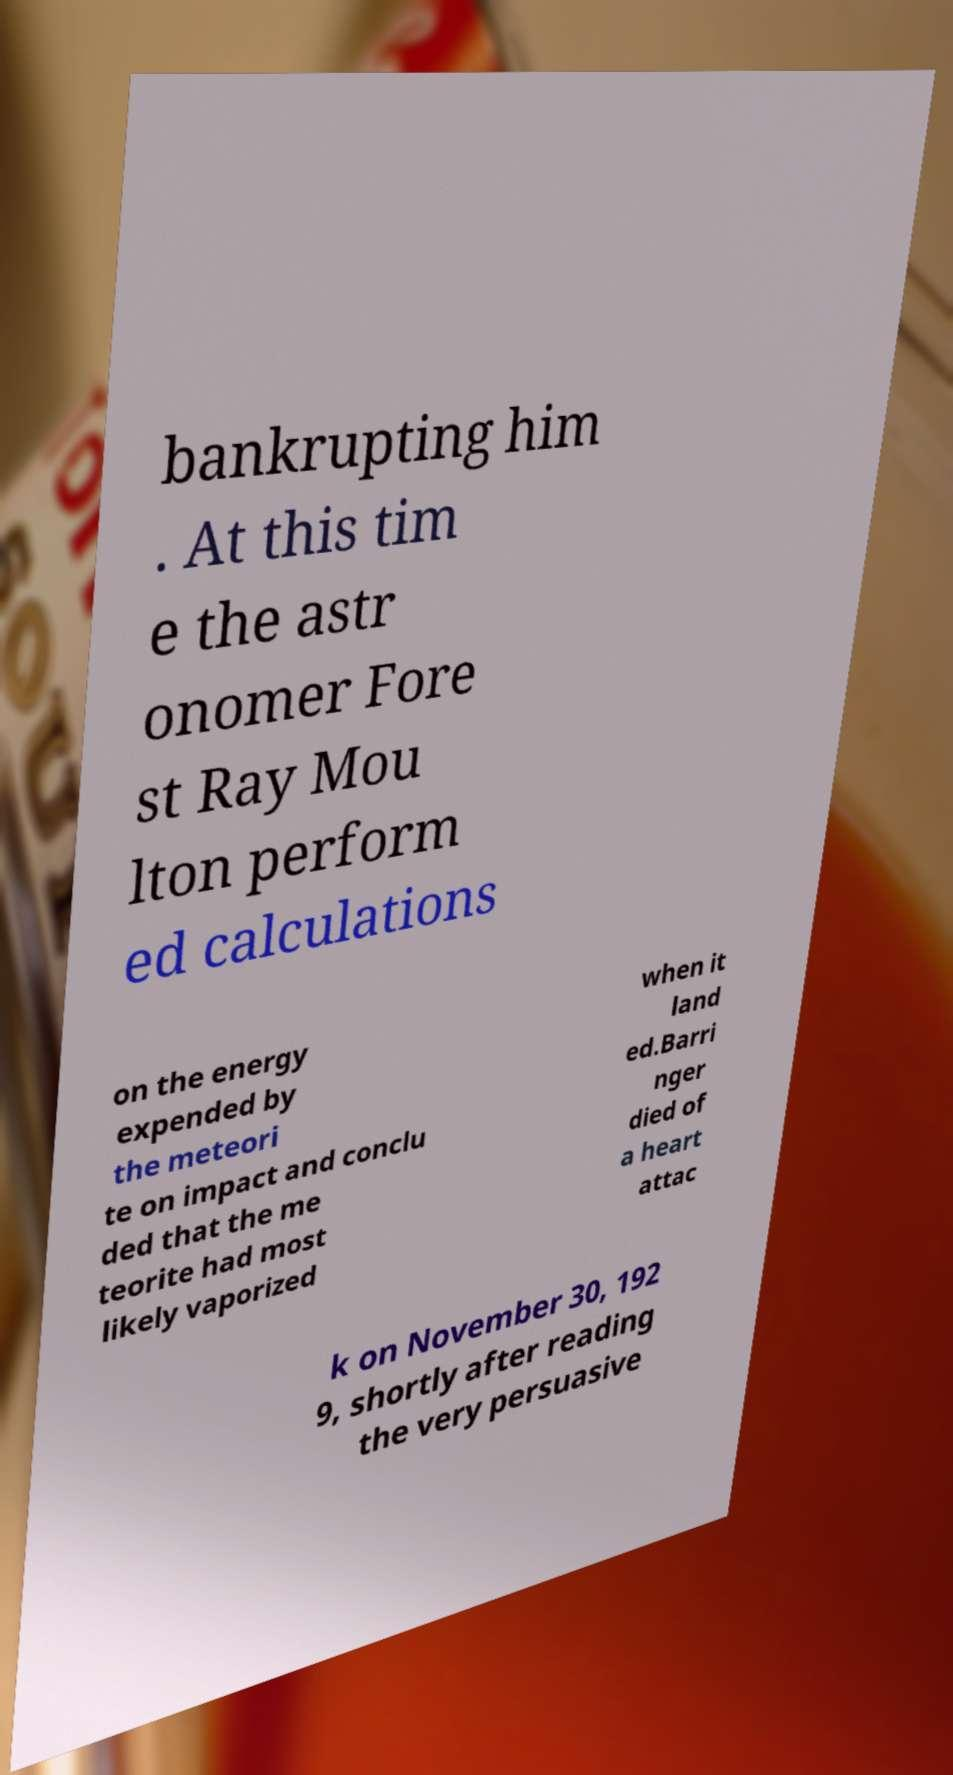There's text embedded in this image that I need extracted. Can you transcribe it verbatim? bankrupting him . At this tim e the astr onomer Fore st Ray Mou lton perform ed calculations on the energy expended by the meteori te on impact and conclu ded that the me teorite had most likely vaporized when it land ed.Barri nger died of a heart attac k on November 30, 192 9, shortly after reading the very persuasive 